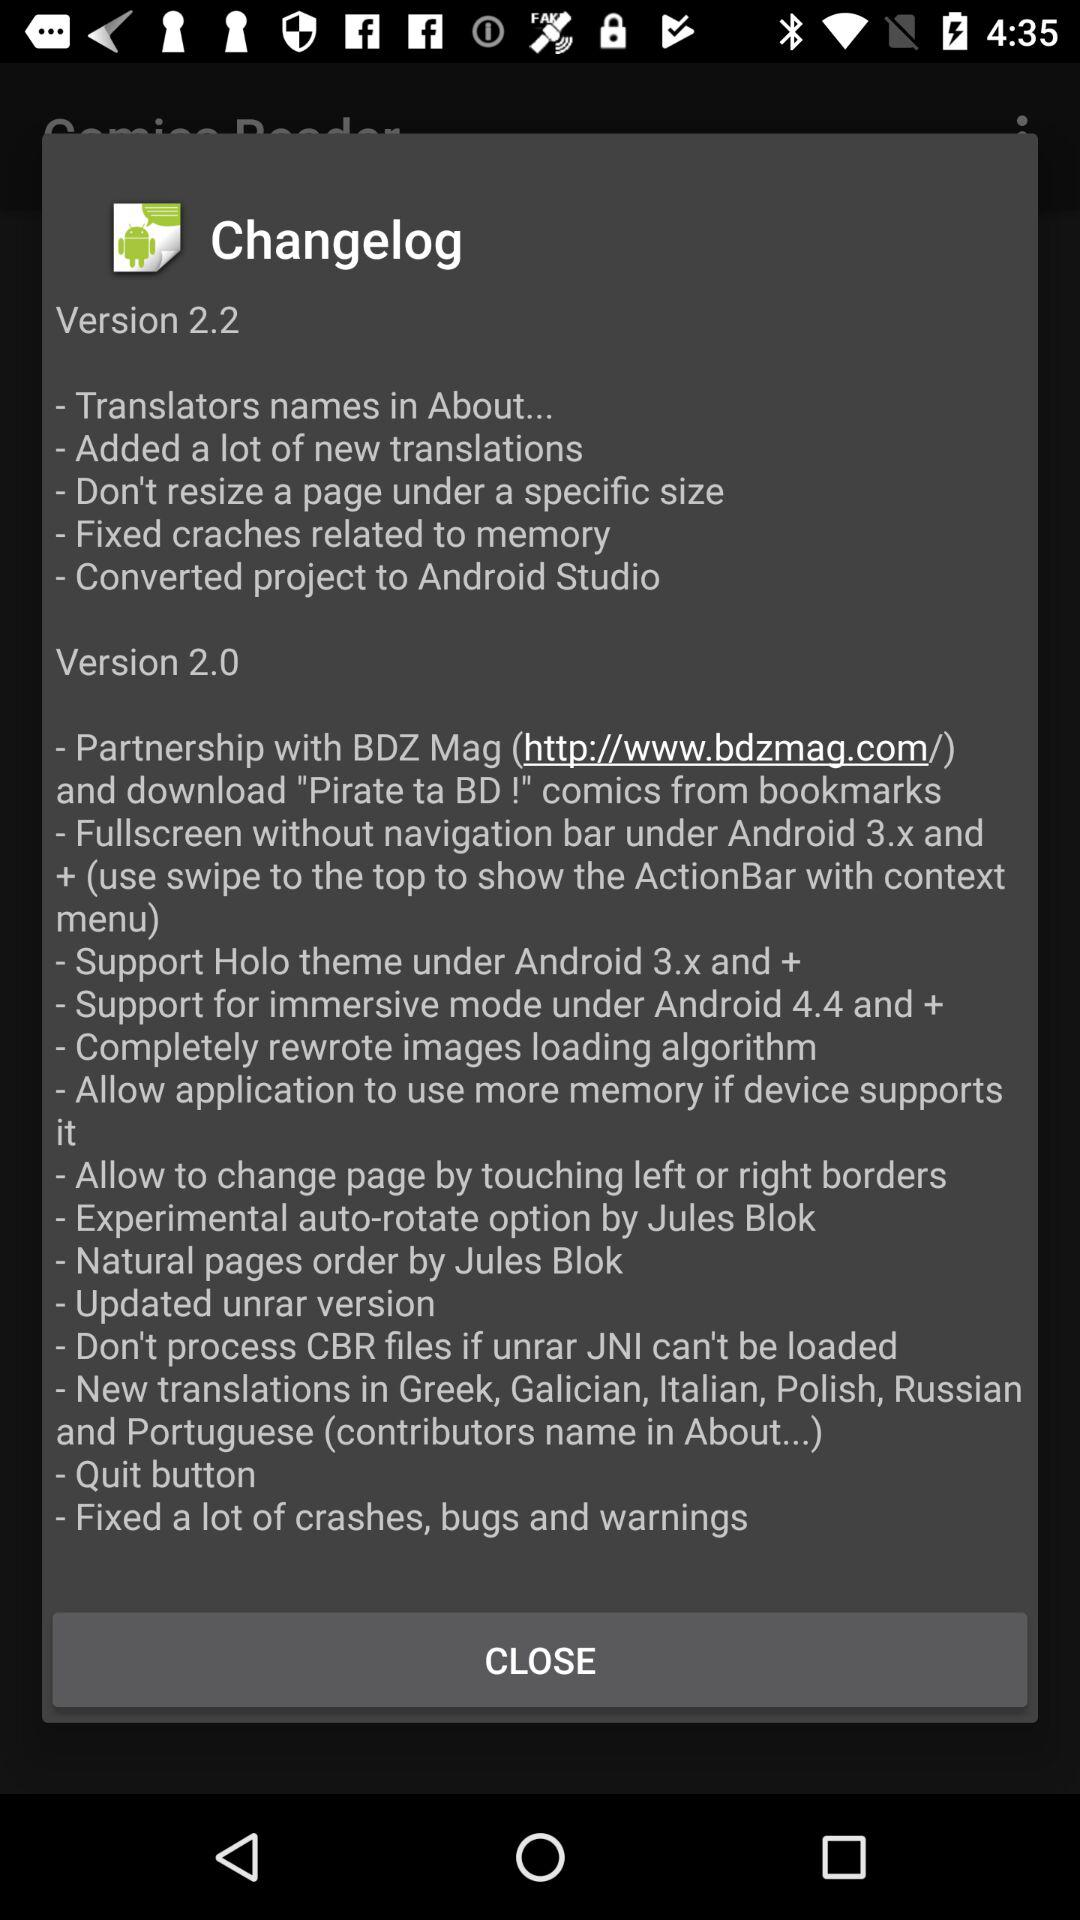What are the updates in version 2.2? The updates are "Translators names in About...", "Added a lot of new translations", "Don't resize a page under a specific size", "Fixed craches related to memory" and "Converted project to Android Studio". 